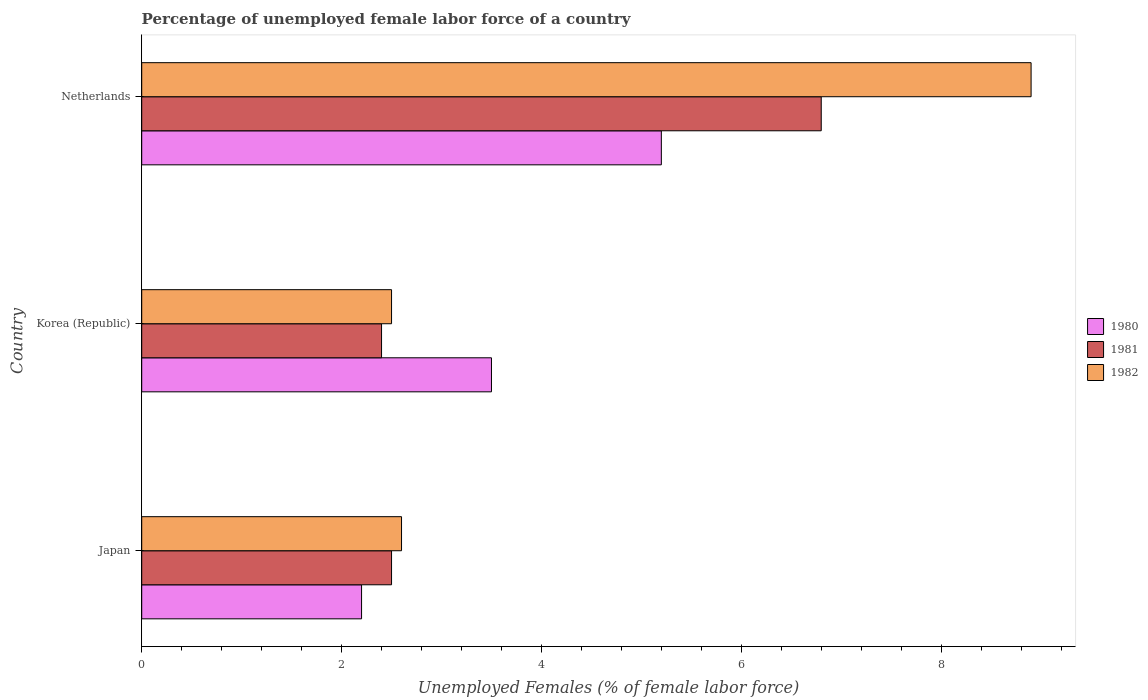How many bars are there on the 1st tick from the top?
Your answer should be compact. 3. What is the label of the 2nd group of bars from the top?
Keep it short and to the point. Korea (Republic). Across all countries, what is the maximum percentage of unemployed female labor force in 1981?
Offer a very short reply. 6.8. Across all countries, what is the minimum percentage of unemployed female labor force in 1981?
Offer a very short reply. 2.4. In which country was the percentage of unemployed female labor force in 1980 maximum?
Your answer should be compact. Netherlands. What is the total percentage of unemployed female labor force in 1980 in the graph?
Your answer should be compact. 10.9. What is the difference between the percentage of unemployed female labor force in 1981 in Korea (Republic) and that in Netherlands?
Provide a succinct answer. -4.4. What is the average percentage of unemployed female labor force in 1981 per country?
Offer a terse response. 3.9. What is the difference between the percentage of unemployed female labor force in 1980 and percentage of unemployed female labor force in 1982 in Netherlands?
Your answer should be compact. -3.7. What is the ratio of the percentage of unemployed female labor force in 1980 in Korea (Republic) to that in Netherlands?
Provide a short and direct response. 0.67. Is the difference between the percentage of unemployed female labor force in 1980 in Japan and Korea (Republic) greater than the difference between the percentage of unemployed female labor force in 1982 in Japan and Korea (Republic)?
Your answer should be very brief. No. What is the difference between the highest and the second highest percentage of unemployed female labor force in 1982?
Keep it short and to the point. 6.3. What is the difference between the highest and the lowest percentage of unemployed female labor force in 1980?
Ensure brevity in your answer.  3. What does the 2nd bar from the bottom in Korea (Republic) represents?
Keep it short and to the point. 1981. Is it the case that in every country, the sum of the percentage of unemployed female labor force in 1982 and percentage of unemployed female labor force in 1981 is greater than the percentage of unemployed female labor force in 1980?
Your answer should be compact. Yes. How many bars are there?
Provide a succinct answer. 9. Are all the bars in the graph horizontal?
Your response must be concise. Yes. How many countries are there in the graph?
Keep it short and to the point. 3. Does the graph contain grids?
Make the answer very short. No. Where does the legend appear in the graph?
Provide a succinct answer. Center right. What is the title of the graph?
Your answer should be very brief. Percentage of unemployed female labor force of a country. What is the label or title of the X-axis?
Keep it short and to the point. Unemployed Females (% of female labor force). What is the Unemployed Females (% of female labor force) in 1980 in Japan?
Make the answer very short. 2.2. What is the Unemployed Females (% of female labor force) of 1981 in Japan?
Offer a very short reply. 2.5. What is the Unemployed Females (% of female labor force) in 1982 in Japan?
Keep it short and to the point. 2.6. What is the Unemployed Females (% of female labor force) of 1981 in Korea (Republic)?
Provide a short and direct response. 2.4. What is the Unemployed Females (% of female labor force) in 1980 in Netherlands?
Make the answer very short. 5.2. What is the Unemployed Females (% of female labor force) of 1981 in Netherlands?
Offer a very short reply. 6.8. What is the Unemployed Females (% of female labor force) in 1982 in Netherlands?
Keep it short and to the point. 8.9. Across all countries, what is the maximum Unemployed Females (% of female labor force) of 1980?
Provide a short and direct response. 5.2. Across all countries, what is the maximum Unemployed Females (% of female labor force) in 1981?
Offer a terse response. 6.8. Across all countries, what is the maximum Unemployed Females (% of female labor force) in 1982?
Offer a terse response. 8.9. Across all countries, what is the minimum Unemployed Females (% of female labor force) of 1980?
Ensure brevity in your answer.  2.2. Across all countries, what is the minimum Unemployed Females (% of female labor force) of 1981?
Your answer should be compact. 2.4. What is the total Unemployed Females (% of female labor force) of 1980 in the graph?
Make the answer very short. 10.9. What is the total Unemployed Females (% of female labor force) in 1982 in the graph?
Offer a very short reply. 14. What is the difference between the Unemployed Females (% of female labor force) in 1981 in Japan and that in Korea (Republic)?
Ensure brevity in your answer.  0.1. What is the difference between the Unemployed Females (% of female labor force) in 1980 in Japan and that in Netherlands?
Make the answer very short. -3. What is the difference between the Unemployed Females (% of female labor force) in 1981 in Japan and that in Netherlands?
Provide a short and direct response. -4.3. What is the difference between the Unemployed Females (% of female labor force) in 1980 in Korea (Republic) and that in Netherlands?
Offer a very short reply. -1.7. What is the difference between the Unemployed Females (% of female labor force) in 1981 in Korea (Republic) and that in Netherlands?
Provide a succinct answer. -4.4. What is the difference between the Unemployed Females (% of female labor force) of 1982 in Korea (Republic) and that in Netherlands?
Provide a succinct answer. -6.4. What is the difference between the Unemployed Females (% of female labor force) of 1980 in Japan and the Unemployed Females (% of female labor force) of 1982 in Korea (Republic)?
Offer a very short reply. -0.3. What is the difference between the Unemployed Females (% of female labor force) in 1981 in Japan and the Unemployed Females (% of female labor force) in 1982 in Korea (Republic)?
Your answer should be very brief. 0. What is the difference between the Unemployed Females (% of female labor force) in 1980 in Japan and the Unemployed Females (% of female labor force) in 1981 in Netherlands?
Offer a terse response. -4.6. What is the difference between the Unemployed Females (% of female labor force) of 1980 in Japan and the Unemployed Females (% of female labor force) of 1982 in Netherlands?
Make the answer very short. -6.7. What is the difference between the Unemployed Females (% of female labor force) of 1981 in Japan and the Unemployed Females (% of female labor force) of 1982 in Netherlands?
Offer a very short reply. -6.4. What is the difference between the Unemployed Females (% of female labor force) of 1980 in Korea (Republic) and the Unemployed Females (% of female labor force) of 1981 in Netherlands?
Keep it short and to the point. -3.3. What is the difference between the Unemployed Females (% of female labor force) of 1980 in Korea (Republic) and the Unemployed Females (% of female labor force) of 1982 in Netherlands?
Ensure brevity in your answer.  -5.4. What is the difference between the Unemployed Females (% of female labor force) in 1981 in Korea (Republic) and the Unemployed Females (% of female labor force) in 1982 in Netherlands?
Offer a terse response. -6.5. What is the average Unemployed Females (% of female labor force) in 1980 per country?
Your response must be concise. 3.63. What is the average Unemployed Females (% of female labor force) of 1982 per country?
Your answer should be compact. 4.67. What is the difference between the Unemployed Females (% of female labor force) of 1980 and Unemployed Females (% of female labor force) of 1981 in Japan?
Give a very brief answer. -0.3. What is the difference between the Unemployed Females (% of female labor force) of 1980 and Unemployed Females (% of female labor force) of 1982 in Japan?
Make the answer very short. -0.4. What is the difference between the Unemployed Females (% of female labor force) in 1981 and Unemployed Females (% of female labor force) in 1982 in Japan?
Give a very brief answer. -0.1. What is the difference between the Unemployed Females (% of female labor force) in 1980 and Unemployed Females (% of female labor force) in 1981 in Korea (Republic)?
Your answer should be compact. 1.1. What is the difference between the Unemployed Females (% of female labor force) in 1980 and Unemployed Females (% of female labor force) in 1982 in Korea (Republic)?
Offer a very short reply. 1. What is the difference between the Unemployed Females (% of female labor force) in 1981 and Unemployed Females (% of female labor force) in 1982 in Korea (Republic)?
Make the answer very short. -0.1. What is the difference between the Unemployed Females (% of female labor force) in 1980 and Unemployed Females (% of female labor force) in 1981 in Netherlands?
Ensure brevity in your answer.  -1.6. What is the difference between the Unemployed Females (% of female labor force) in 1981 and Unemployed Females (% of female labor force) in 1982 in Netherlands?
Keep it short and to the point. -2.1. What is the ratio of the Unemployed Females (% of female labor force) of 1980 in Japan to that in Korea (Republic)?
Keep it short and to the point. 0.63. What is the ratio of the Unemployed Females (% of female labor force) of 1981 in Japan to that in Korea (Republic)?
Provide a short and direct response. 1.04. What is the ratio of the Unemployed Females (% of female labor force) of 1980 in Japan to that in Netherlands?
Provide a short and direct response. 0.42. What is the ratio of the Unemployed Females (% of female labor force) in 1981 in Japan to that in Netherlands?
Keep it short and to the point. 0.37. What is the ratio of the Unemployed Females (% of female labor force) of 1982 in Japan to that in Netherlands?
Your answer should be compact. 0.29. What is the ratio of the Unemployed Females (% of female labor force) in 1980 in Korea (Republic) to that in Netherlands?
Your answer should be very brief. 0.67. What is the ratio of the Unemployed Females (% of female labor force) in 1981 in Korea (Republic) to that in Netherlands?
Give a very brief answer. 0.35. What is the ratio of the Unemployed Females (% of female labor force) in 1982 in Korea (Republic) to that in Netherlands?
Your answer should be very brief. 0.28. What is the difference between the highest and the lowest Unemployed Females (% of female labor force) in 1982?
Ensure brevity in your answer.  6.4. 